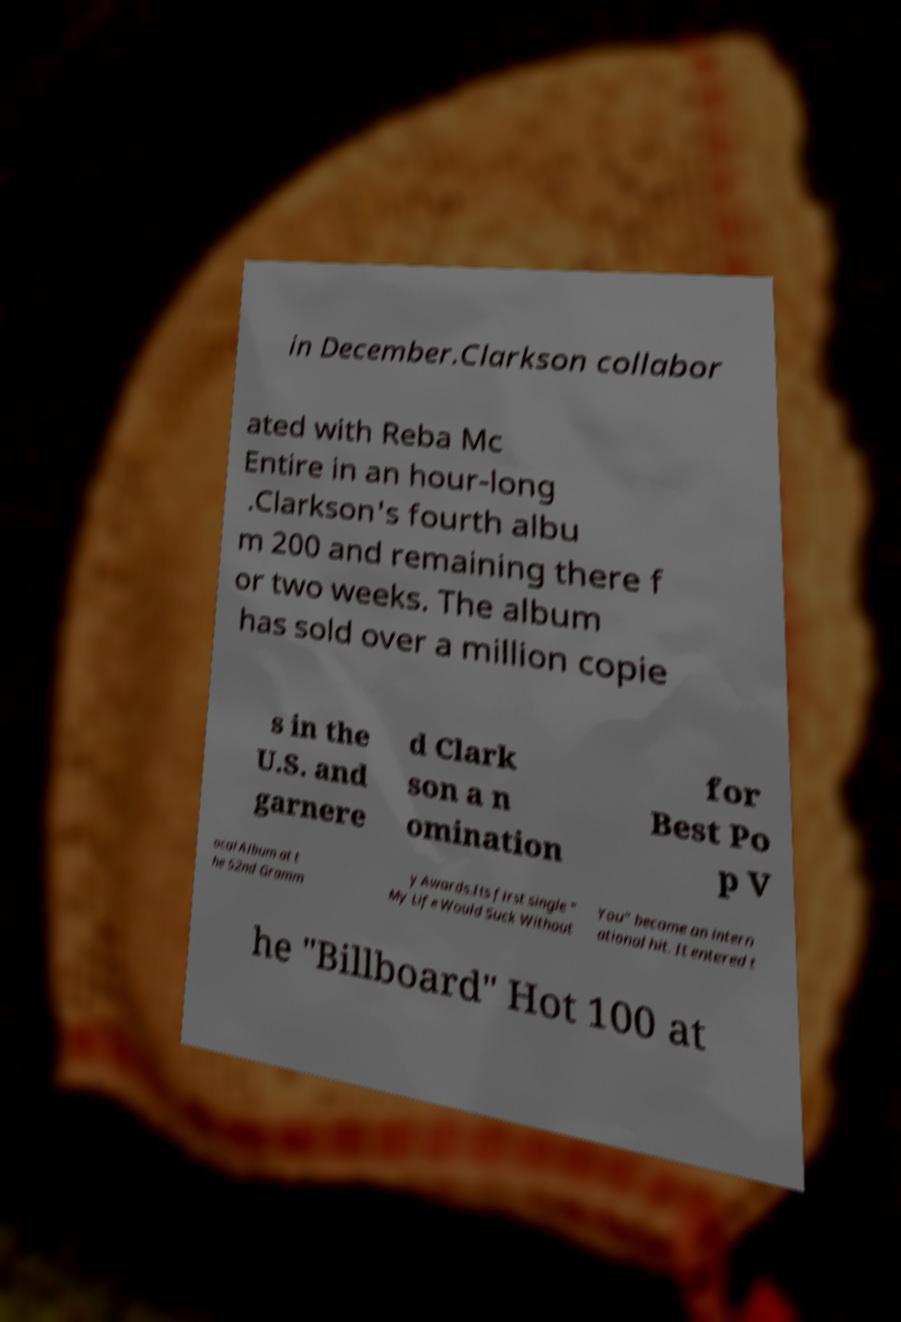Please identify and transcribe the text found in this image. in December.Clarkson collabor ated with Reba Mc Entire in an hour-long .Clarkson's fourth albu m 200 and remaining there f or two weeks. The album has sold over a million copie s in the U.S. and garnere d Clark son a n omination for Best Po p V ocal Album at t he 52nd Gramm y Awards.Its first single " My Life Would Suck Without You" became an intern ational hit. It entered t he "Billboard" Hot 100 at 